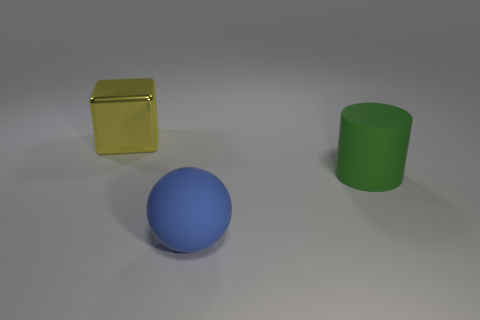Can you describe the lighting and mood of this scene? The lighting in the scene is soft and diffuse, coming from an overhead source, casting gentle shadows and suggesting a tranquil, perhaps sterile environment. The mood is neutral, bordering on clinical due to the lack of any distinct context or personal objects. 